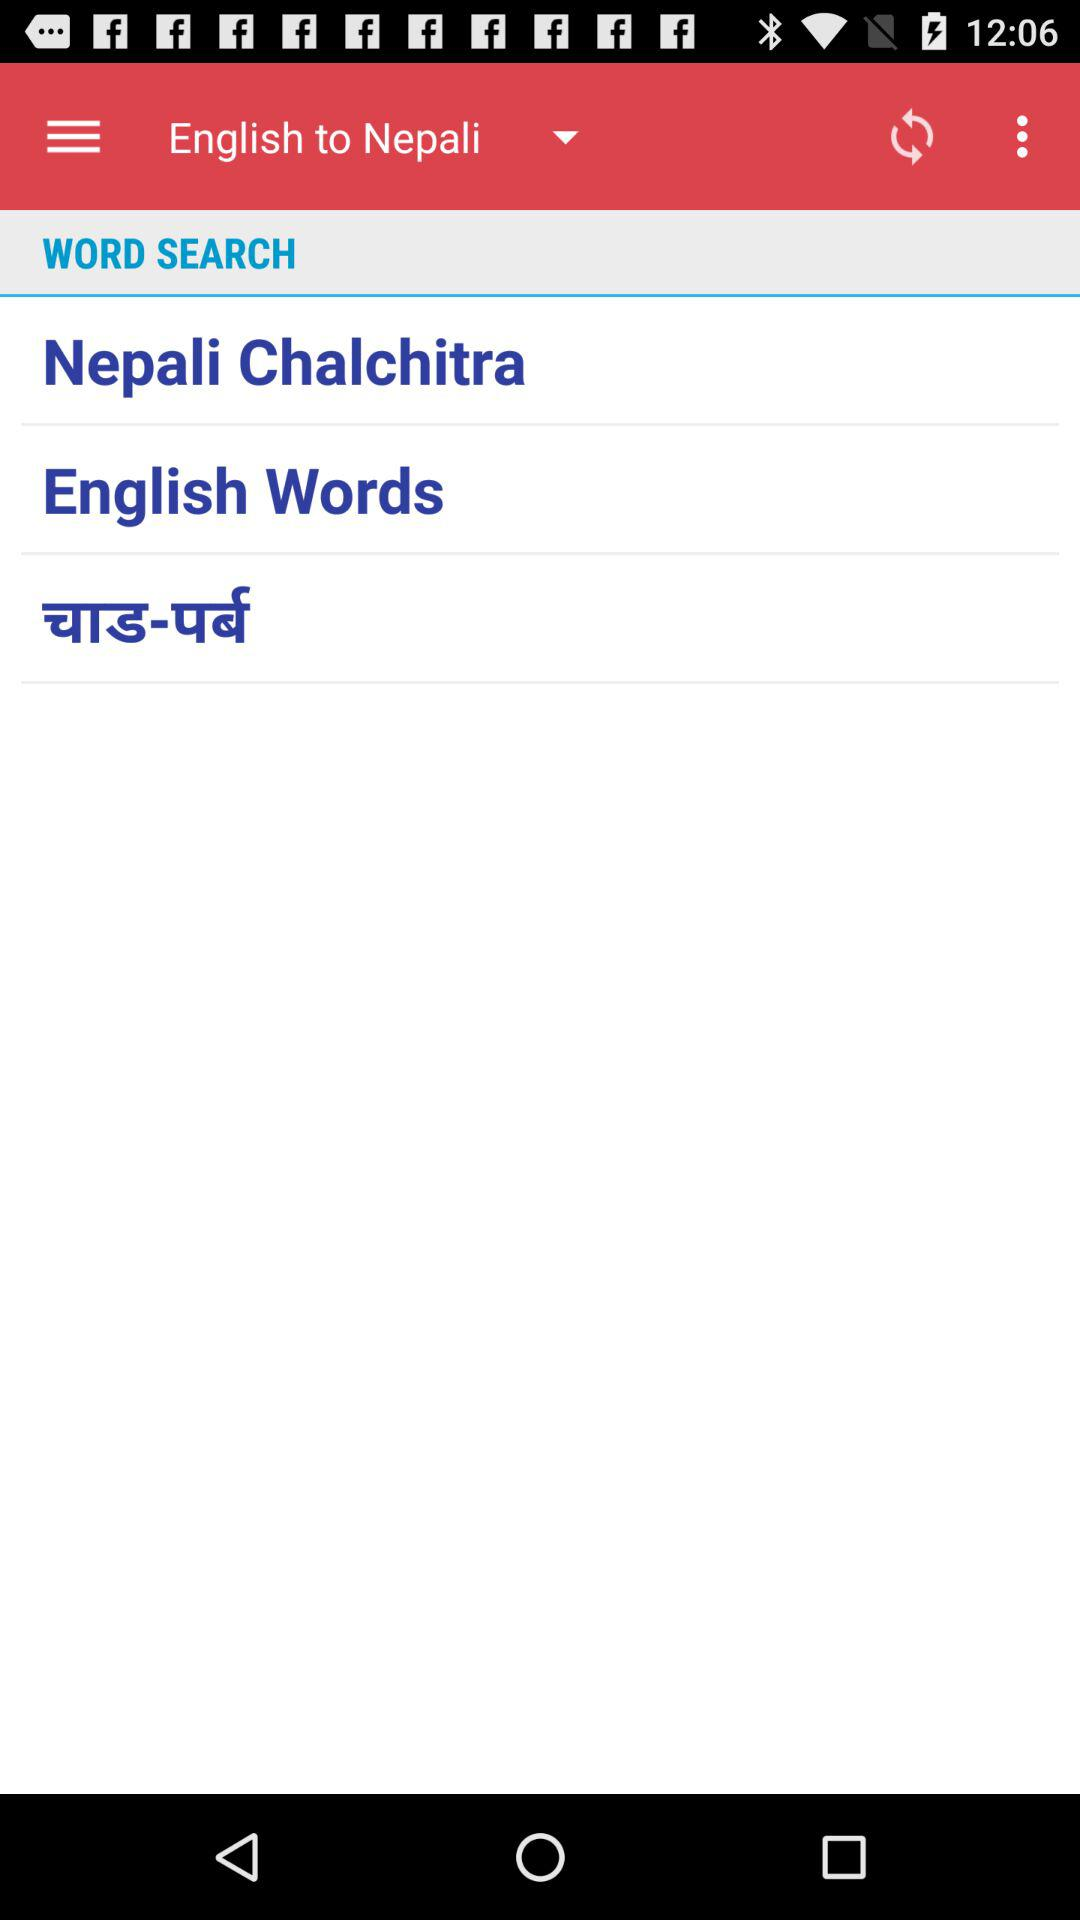Which language is translated into Nepali? The language that is translated into Nepali is English. 